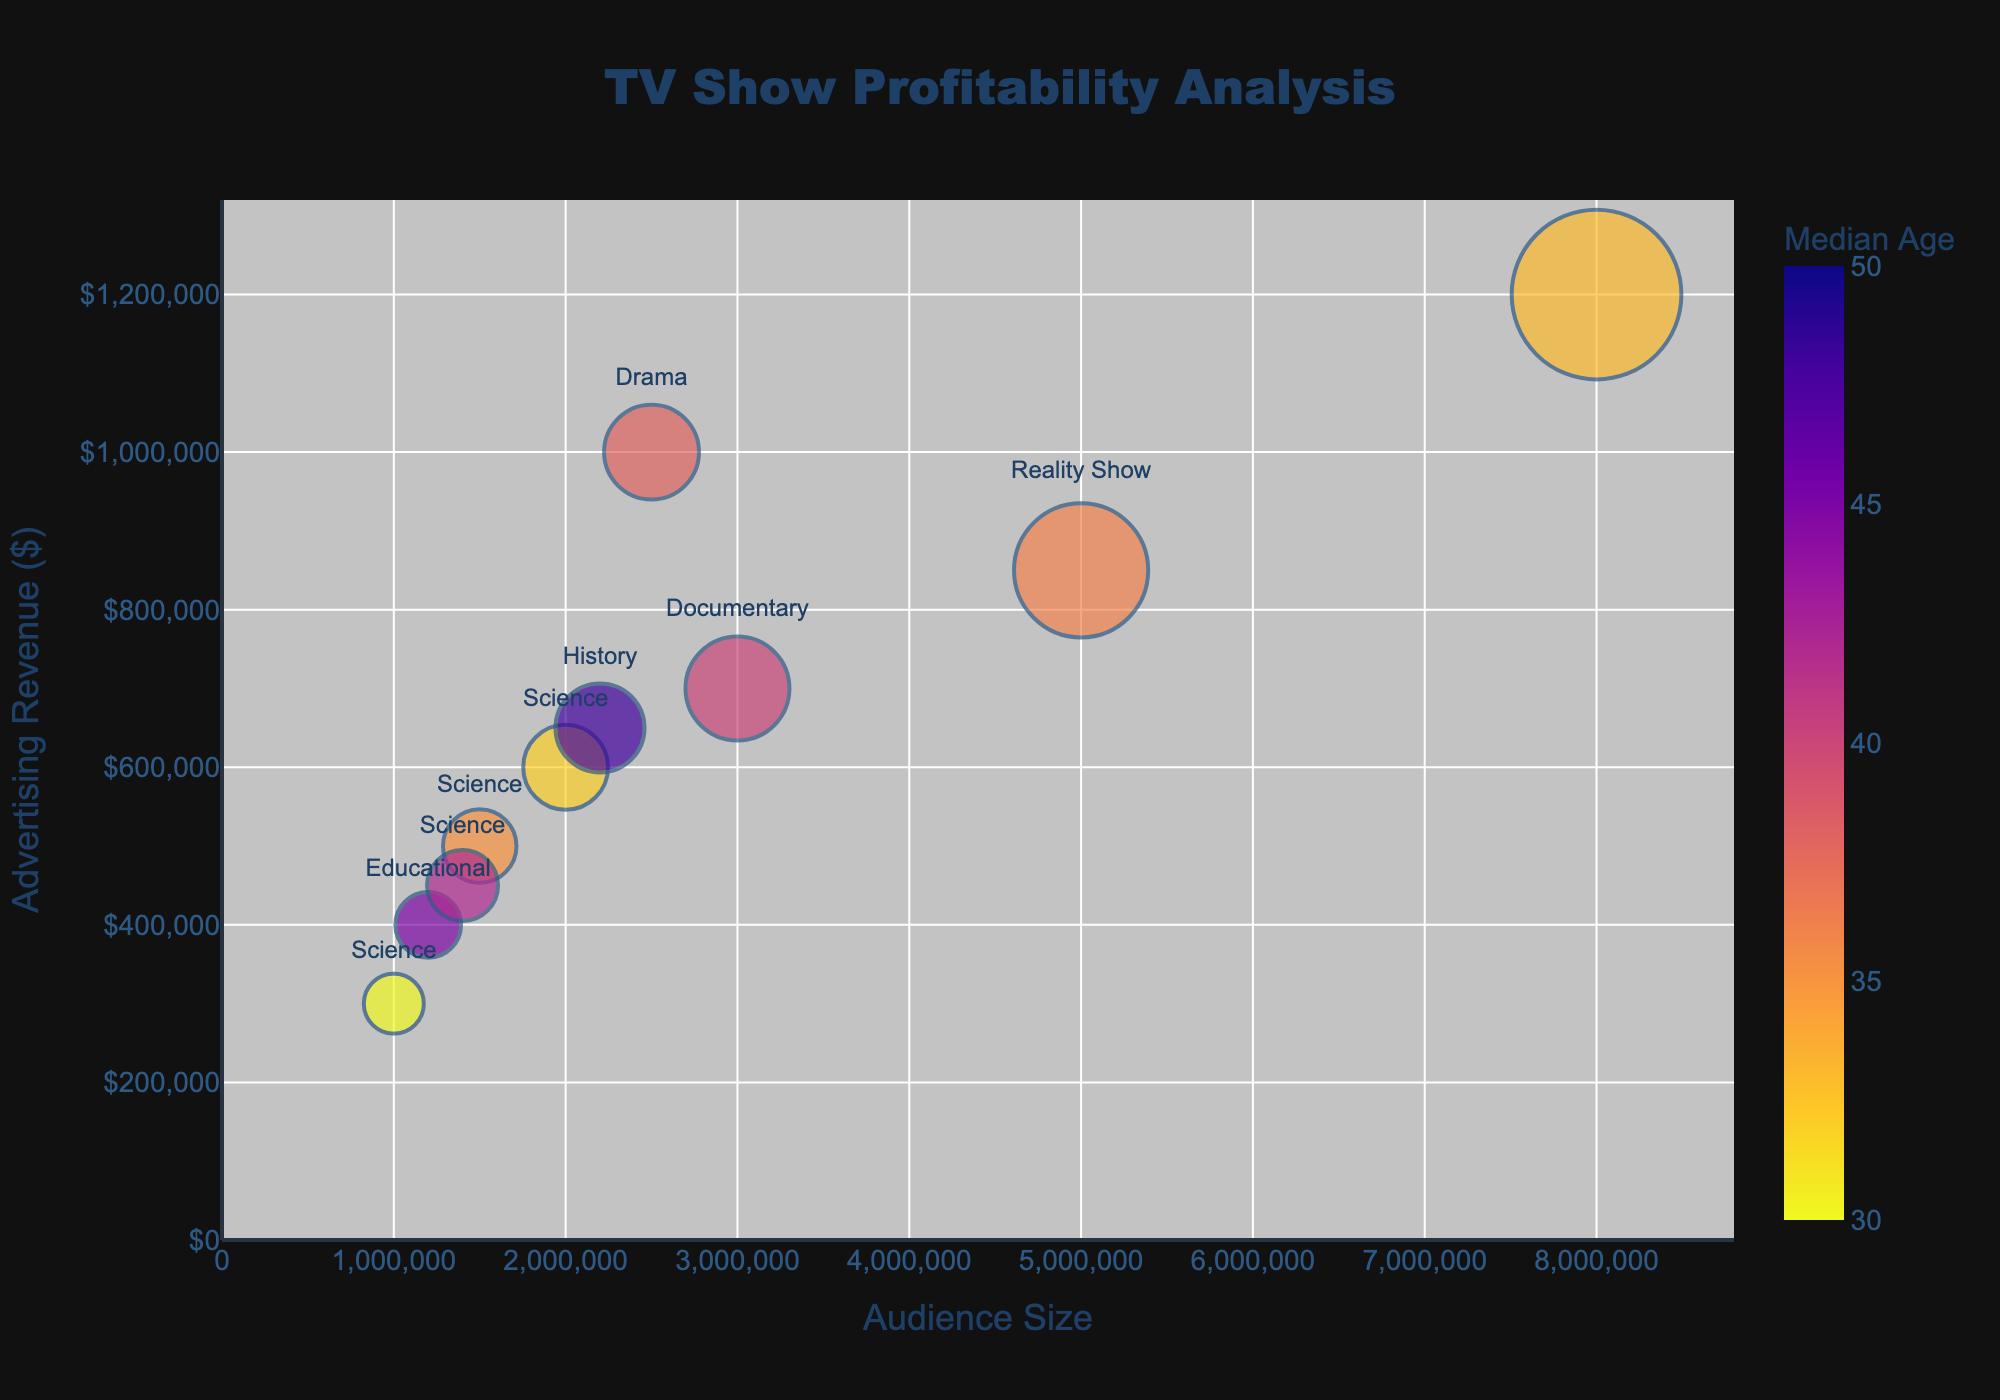What is the title of the chart? The title is displayed prominently at the top of the chart. It provides a brief overview of what the chart is about.
Answer: TV Show Profitability Analysis How many TV shows are categorized under the genre 'Science'? By examining the different 'Science' labels on the chart, we can count the number of Science TV shows represented by the transparent bubbles.
Answer: 4 What is the highest advertising revenue among Science shows? By locating the bubbles labeled with the 'Science' genre and looking at their y-axis positions, which represent advertising revenue, we find the bubble with the highest position.
Answer: $600,000 Which TV show has the largest audience size? By referencing the bubbles' sizes which correspond to audience size, the largest bubble indicates the TV show with the largest audience.
Answer: The Big Bang Theory What is the median age of the audience for the show with the highest advertising revenue? The highest position on the y-axis represents the show with the highest advertising revenue. Hovering over or referencing the color or legend will show its median age.
Answer: 33 Compare the advertising revenue of 'Survivor' and 'Nova'. Which one is higher? Locate the bubbles for 'Survivor' and 'Nova' then compare their y-axis values, which represent advertising revenue.
Answer: Survivor What is the median audience size of Science TV shows? First, find the audience sizes of all Science shows: 1,500,000; 1,000,000; 2,000,000; 1,400,000. Sort these values and find the middle values, then calculate the average of these middle values if necessary.
Answer: 1,450,000 Which TV show has a higher advertising revenue, 'Breaking Bad' or 'The Cosmos'? Locate the bubbles for 'Breaking Bad' and 'The Cosmos,' then compare their y-axis positions.
Answer: Breaking Bad What is the average median age of the audience for Science TV shows? List the median ages of Science shows: 35, 30, 32, 42. Then find their average by adding them and dividing by the number of shows.
Answer: 34.75 Which TV show has the smallest bubble size and what does it represent? The smallest bubble represents the show with the smallest audience size. Identifying this bubble will show the corresponding TV show and its audience size.
Answer: Fictional Science, 1,000,000 